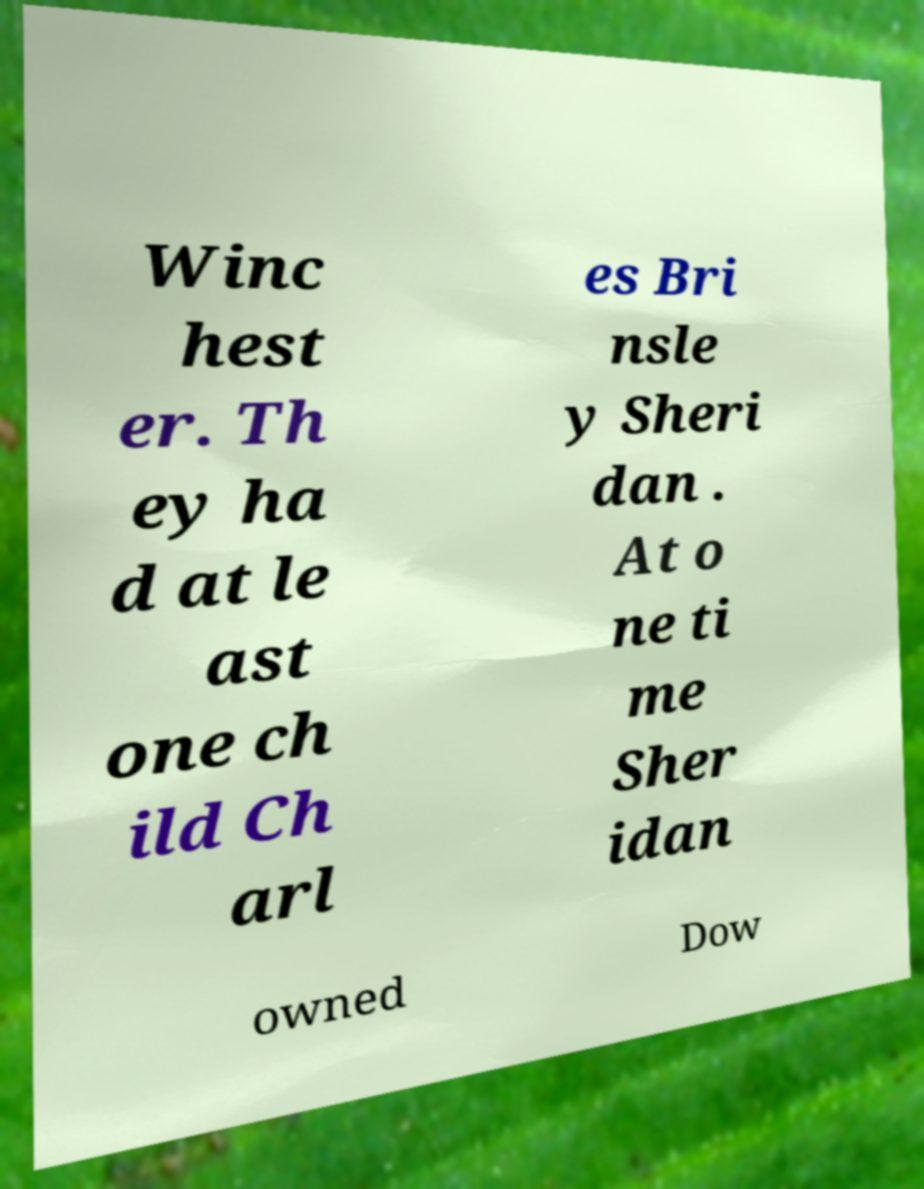I need the written content from this picture converted into text. Can you do that? Winc hest er. Th ey ha d at le ast one ch ild Ch arl es Bri nsle y Sheri dan . At o ne ti me Sher idan owned Dow 